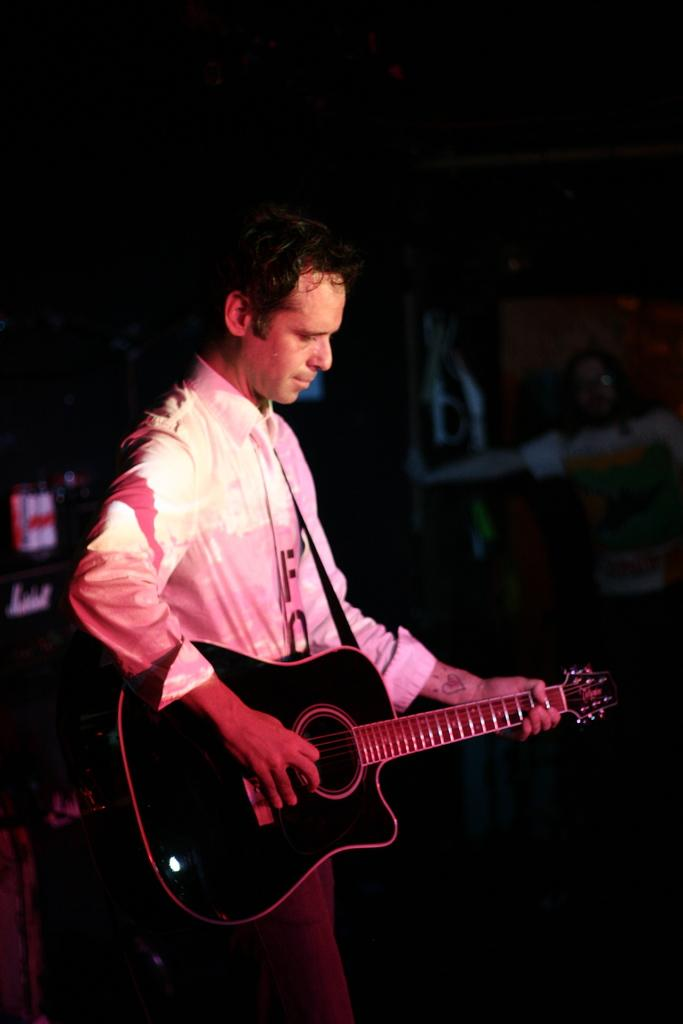What is the man in the image holding? The man is holding a guitar. What can be seen behind the man in the image? The background of the man is black. Can you describe the person standing on the floor in the image? The person standing on the floor is not described in the provided facts, so we cannot provide any details about them. What type of brush is the man using to paint the orange in the image? There is no brush, orange, or painting activity present in the image. 